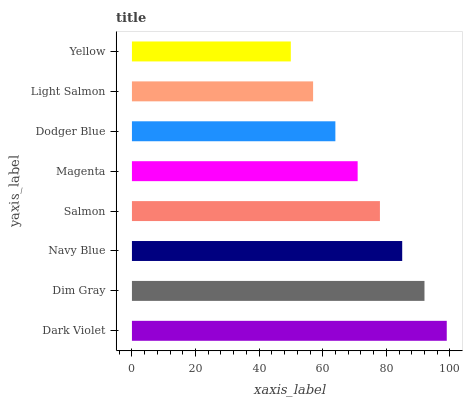Is Yellow the minimum?
Answer yes or no. Yes. Is Dark Violet the maximum?
Answer yes or no. Yes. Is Dim Gray the minimum?
Answer yes or no. No. Is Dim Gray the maximum?
Answer yes or no. No. Is Dark Violet greater than Dim Gray?
Answer yes or no. Yes. Is Dim Gray less than Dark Violet?
Answer yes or no. Yes. Is Dim Gray greater than Dark Violet?
Answer yes or no. No. Is Dark Violet less than Dim Gray?
Answer yes or no. No. Is Salmon the high median?
Answer yes or no. Yes. Is Magenta the low median?
Answer yes or no. Yes. Is Yellow the high median?
Answer yes or no. No. Is Dodger Blue the low median?
Answer yes or no. No. 